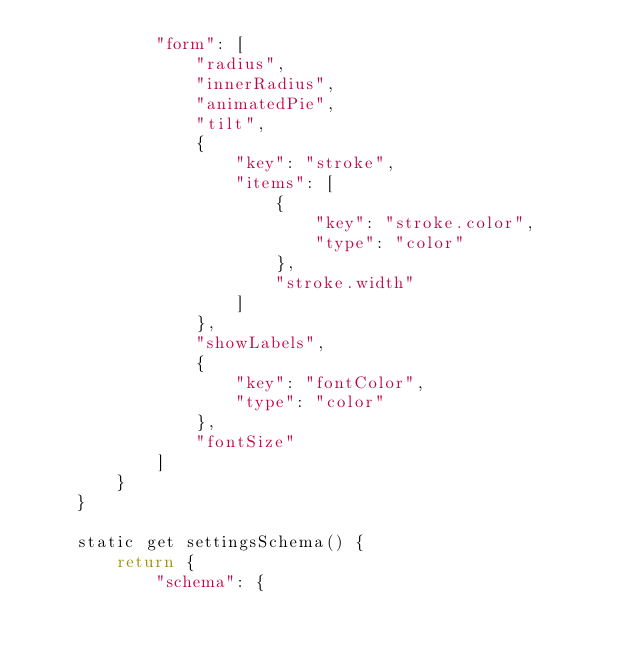Convert code to text. <code><loc_0><loc_0><loc_500><loc_500><_JavaScript_>            "form": [
                "radius",
                "innerRadius",
                "animatedPie",
                "tilt",
                {
                    "key": "stroke",
                    "items": [
                        {
                            "key": "stroke.color",
                            "type": "color"
                        },
                        "stroke.width"
                    ]
                },
                "showLabels",
                {
                    "key": "fontColor",
                    "type": "color"
                },
                "fontSize"
            ]
        }
    }

    static get settingsSchema() {
        return {
            "schema": {</code> 